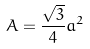Convert formula to latex. <formula><loc_0><loc_0><loc_500><loc_500>A = \frac { \sqrt { 3 } } { 4 } a ^ { 2 }</formula> 